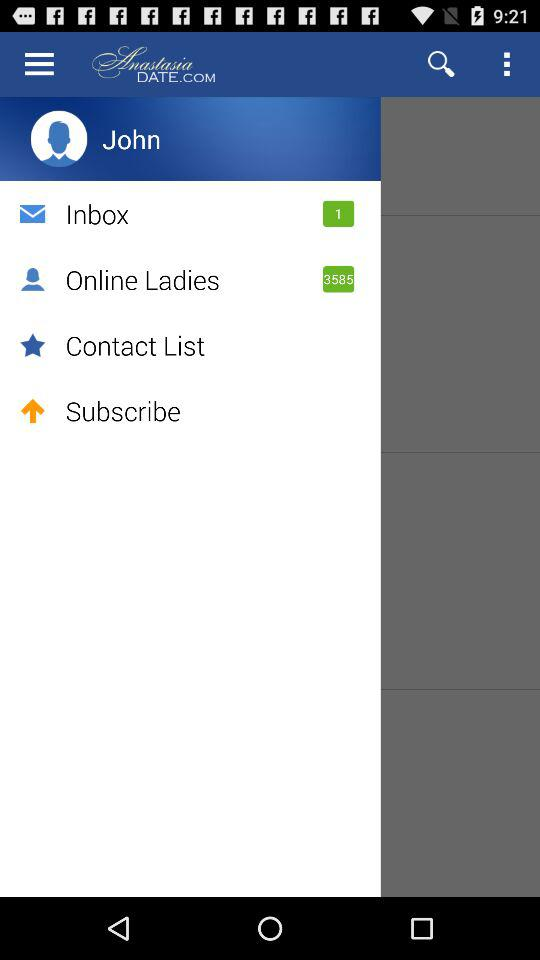How many ladies are online? There are 3585 ladies online. 